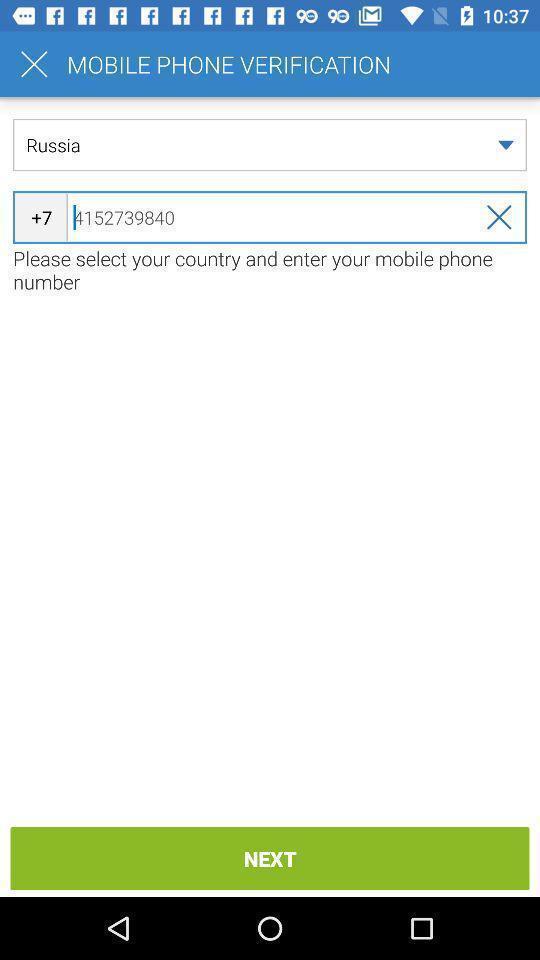Describe the content in this image. Page asking phone number on a financial app. 